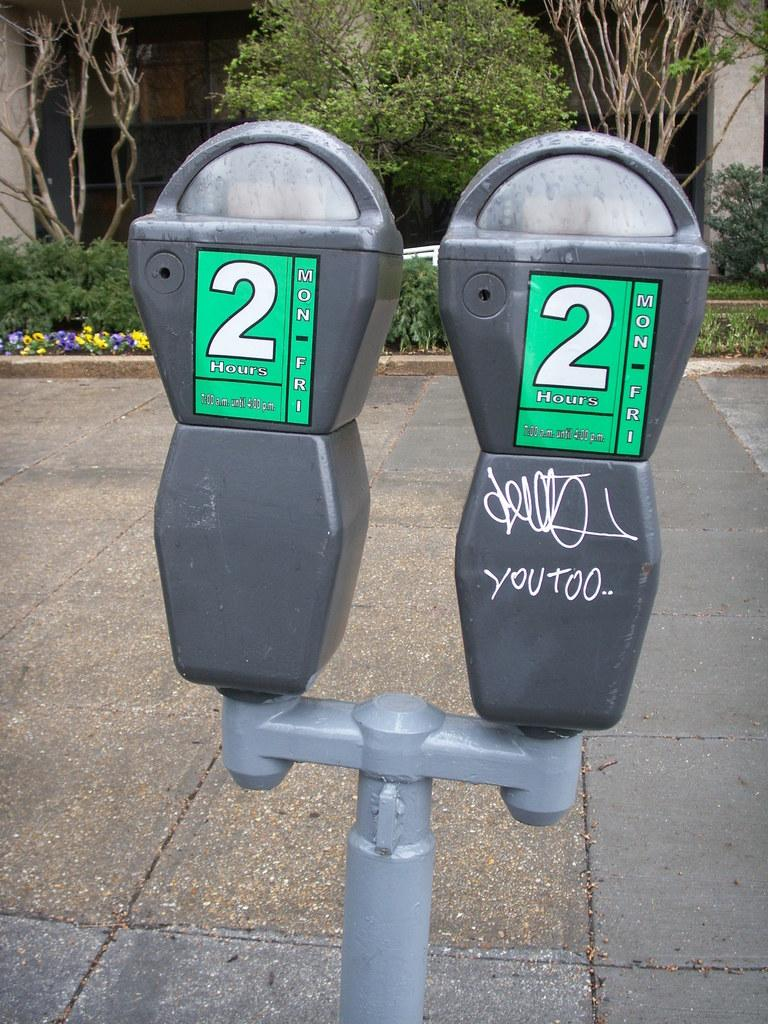<image>
Give a short and clear explanation of the subsequent image. Two parking meters next to each other that say 2 hours Mon-Fri on it. 